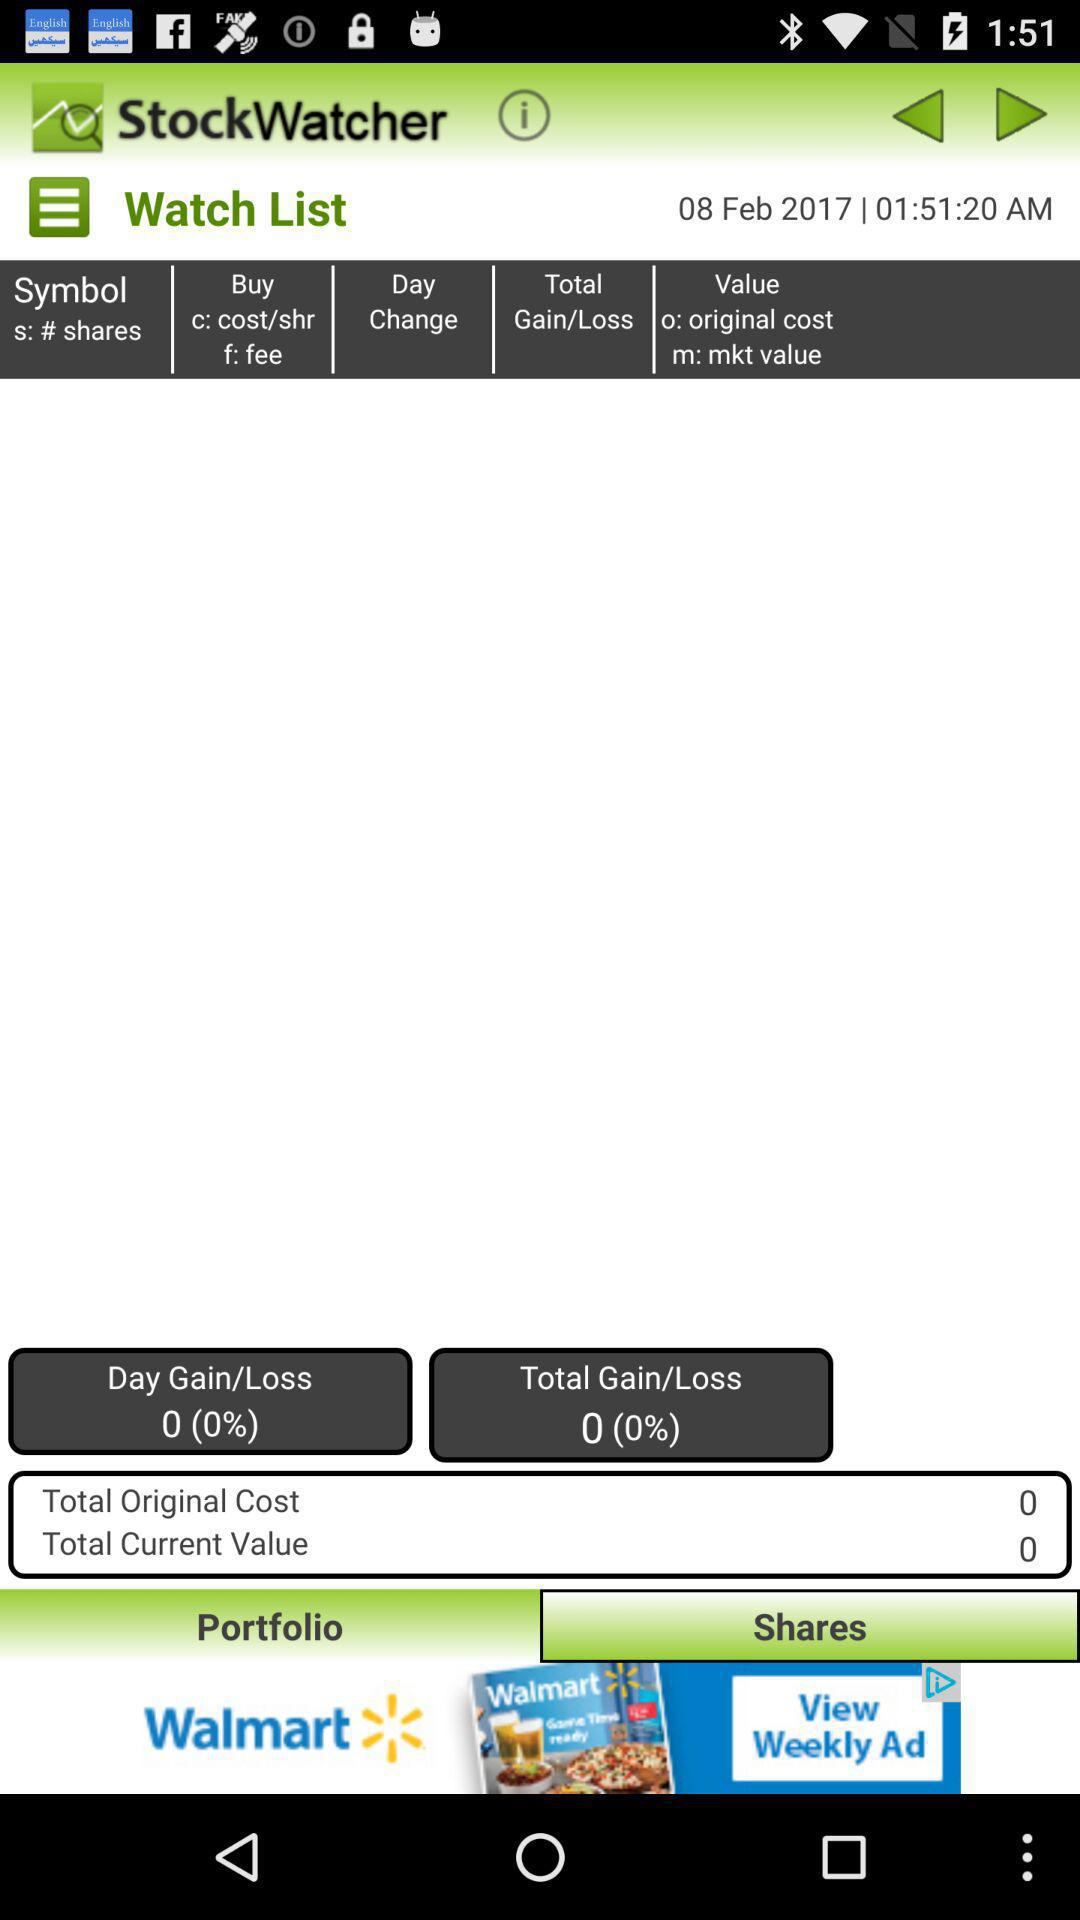What is the date? The date is February 8, 2017. 